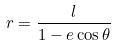<formula> <loc_0><loc_0><loc_500><loc_500>r = \frac { l } { 1 - e \cos \theta }</formula> 